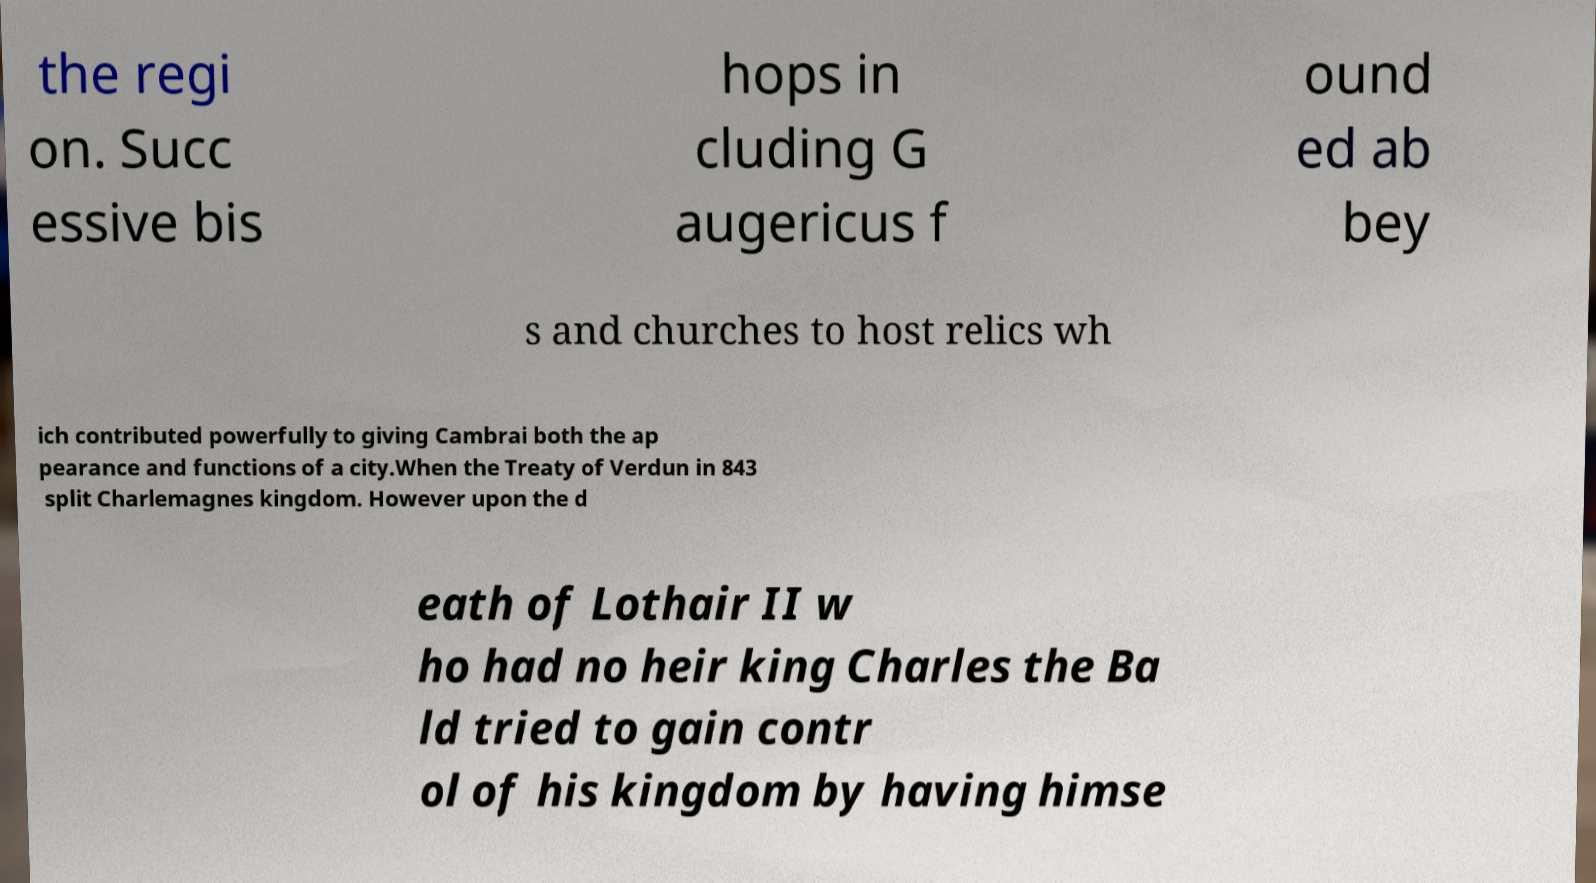For documentation purposes, I need the text within this image transcribed. Could you provide that? the regi on. Succ essive bis hops in cluding G augericus f ound ed ab bey s and churches to host relics wh ich contributed powerfully to giving Cambrai both the ap pearance and functions of a city.When the Treaty of Verdun in 843 split Charlemagnes kingdom. However upon the d eath of Lothair II w ho had no heir king Charles the Ba ld tried to gain contr ol of his kingdom by having himse 